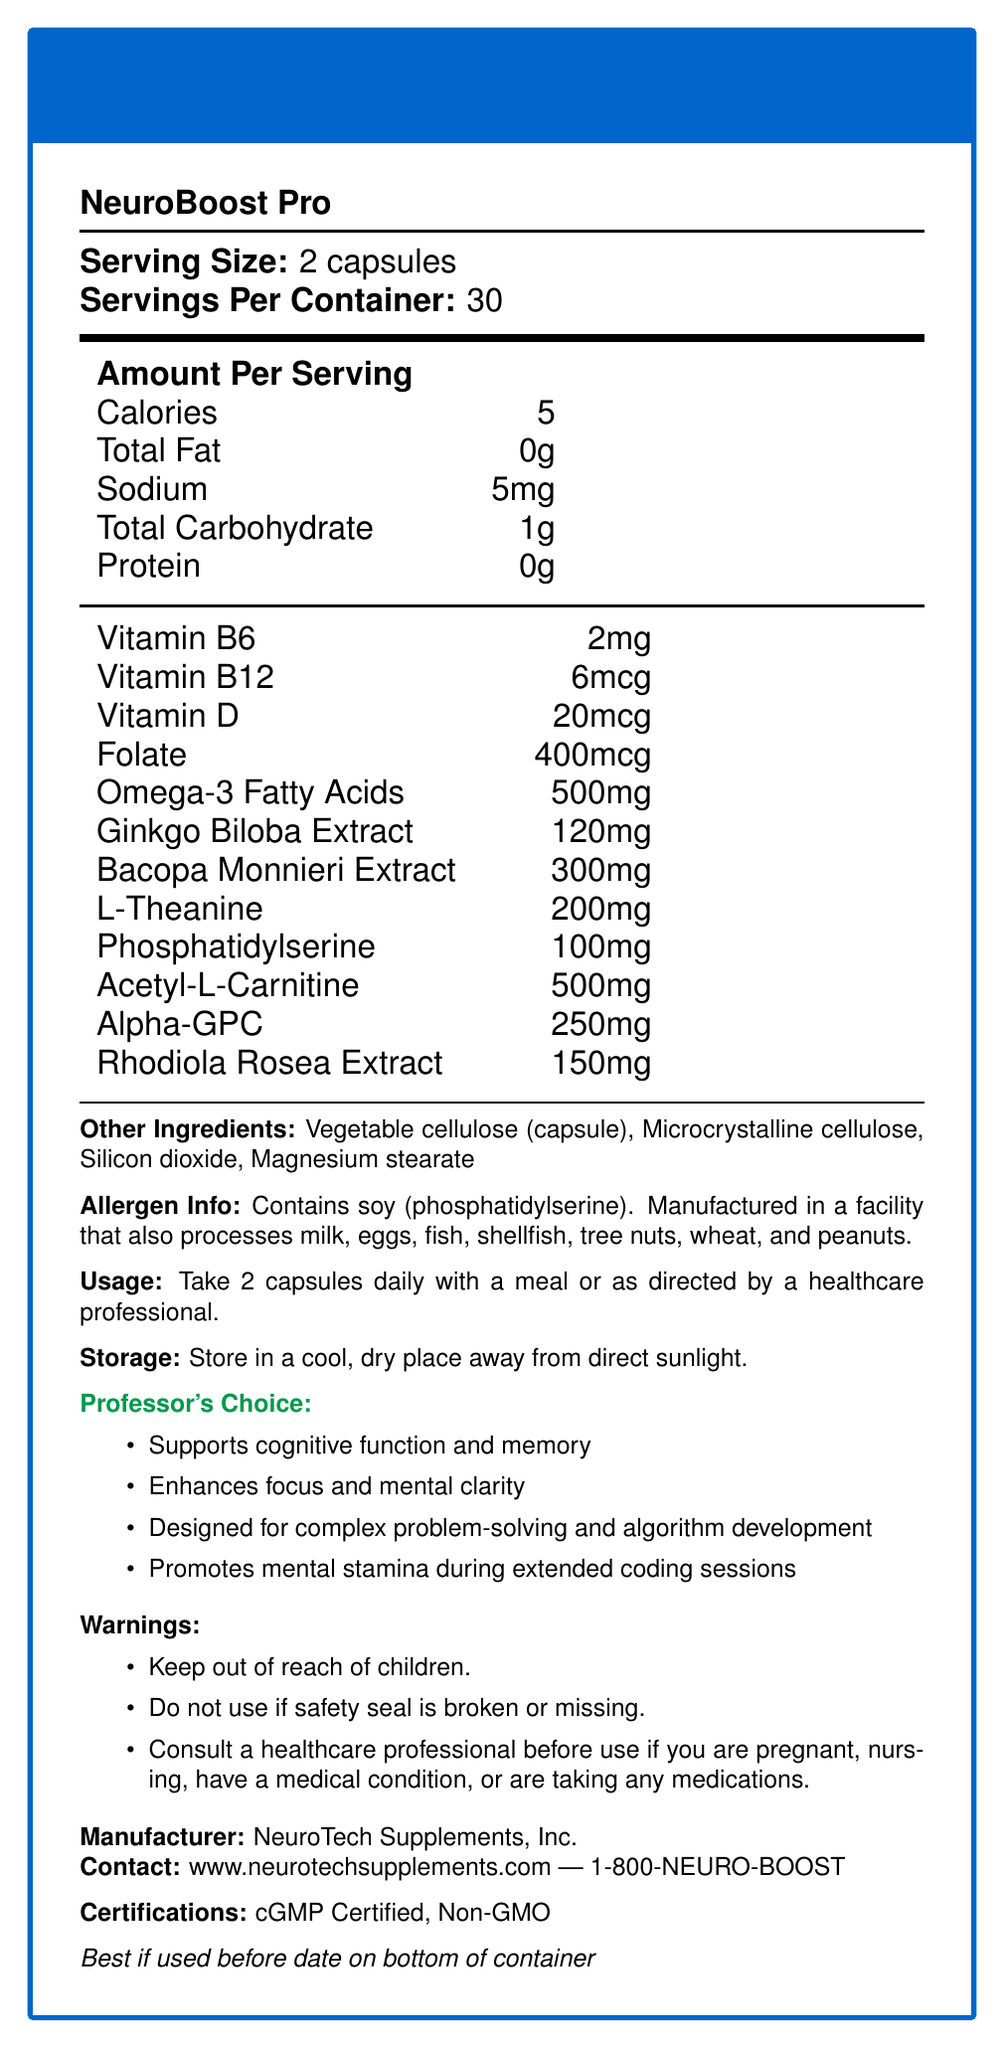what is the serving size of NeuroBoost Pro? The serving size is explicitly stated as "2 capsules" in the document.
Answer: 2 capsules how many servings are there per container? The document specifies the number of servings per container as 30.
Answer: 30 how many calories are in one serving of NeuroBoost Pro? The document lists the amount per serving as 5 calories.
Answer: 5 calories list the key vitamins found in NeuroBoost Pro The document lists Vitamin B6, Vitamin B12, Vitamin D, and Folate in the nutrition facts.
Answer: Vitamin B6, Vitamin B12, Vitamin D, Folate what is the amount of Omega-3 Fatty Acids per serving? The document shows that each serving contains 500mg of Omega-3 Fatty Acids.
Answer: 500mg what is the suggested usage of NeuroBoost Pro? A. Take 1 capsule daily B. Take 2 capsules daily with a meal C. Take 3 capsules daily D. Take 2 capsules daily on an empty stomach The document provides usage instructions, which state that 2 capsules should be taken daily with a meal.
Answer: B. Take 2 capsules daily with a meal what are the forms of certification for NeuroBoost Pro? A. Organic B. cGMP Certified C. Non-GMO D. Both B and C The document lists NeuroBoost Pro as being cGMP Certified and Non-GMO.
Answer: D. Both B and C does NeuroBoost Pro contain allergenic ingredients? The document mentions that it contains soy and is manufactured in a facility that processes several common allergens.
Answer: Yes describe the main purpose of NeuroBoost Pro The document outlines that the product is designed to enhance cognitive function, memory, focus, mental clarity, and support brain health, particularly for high-performance individuals and researchers.
Answer: NeuroBoost Pro is a brain-boosting supplement that supports cognitive function, memory, mental clarity, brain health, and is optimized for high-performance individuals such as researchers and professors. can you use NeuroBoost Pro if the safety seal is broken? The document clearly states not to use the product if the safety seal is broken or missing.
Answer: No list two specific extracts contained in NeuroBoost Pro These two extracts are specifically listed among the ingredients in the nutrition facts.
Answer: Ginkgo Biloba Extract, Bacopa Monnieri Extract what is the main type of ingredient in NeuroBoost Pro capsules? The document states that the capsule material is vegetable cellulose.
Answer: Vegetable cellulose what should you do if you are pregnant and want to use NeuroBoost Pro? The document provides a warning to consult a healthcare professional if pregnant.
Answer: Consult a healthcare professional how much L-Theanine is in each serving of NeuroBoost Pro? The document lists L-Theanine as 200mg per serving.
Answer: 200mg is NeuroBoost Pro gluten-free? The document does not provide information on whether NeuroBoost Pro is gluten-free or not.
Answer: Cannot be determined who is the manufacturer of NeuroBoost Pro? The document provides this information under the manufacturer section.
Answer: NeuroTech Supplements, Inc. what is the website for contacting the manufacturer? The contact information section in the document provides this URL.
Answer: www.neurotechsupplements.com when is it best to use NeuroBoost Pro? The document advises checking the bottom of the container for the best-use date.
Answer: Best if used before date on bottom of container how much Acetyl-L-Carnitine is in each serving? The document lists Acetyl-L-Carnitine as 500mg per serving.
Answer: 500mg what can NeuroBoost Pro potentially enhance for someone managing research teams and teaching responsibilities? The professor-specific information mentions enhancing multitasking abilities for managing research teams and teaching responsibilities.
Answer: Multitasking abilities 